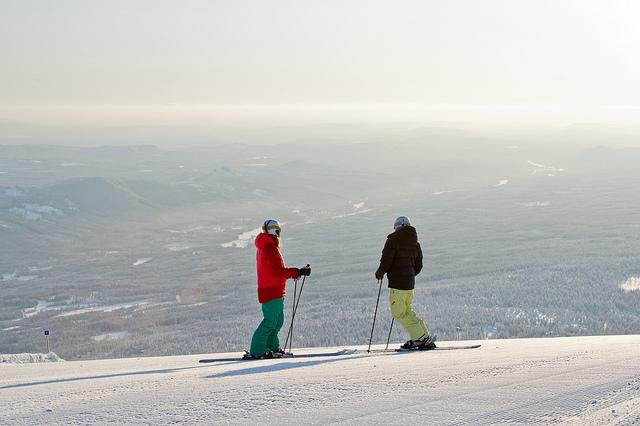Are they cross country skiing?
Give a very brief answer. Yes. What color is the person's helmet?
Give a very brief answer. White. Is it daytime or nighttime?
Write a very short answer. Daytime. Is this one male and one female?
Keep it brief. No. What is this person doing with their skis?
Answer briefly. Standing. How many skiers are on the slope?
Be succinct. 2. Where was the picture taken?
Quick response, please. Mountains. Is there any dust in this picture?
Write a very short answer. No. 